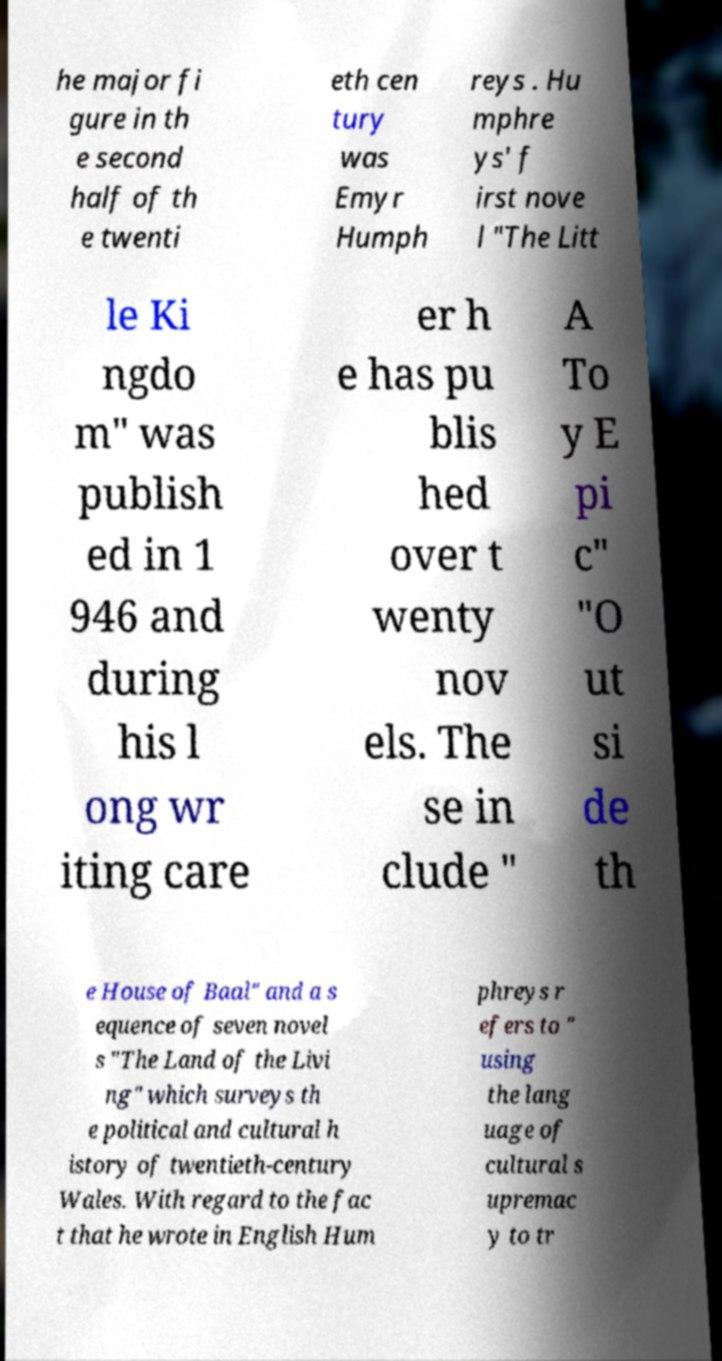For documentation purposes, I need the text within this image transcribed. Could you provide that? he major fi gure in th e second half of th e twenti eth cen tury was Emyr Humph reys . Hu mphre ys' f irst nove l "The Litt le Ki ngdo m" was publish ed in 1 946 and during his l ong wr iting care er h e has pu blis hed over t wenty nov els. The se in clude " A To y E pi c" "O ut si de th e House of Baal" and a s equence of seven novel s "The Land of the Livi ng" which surveys th e political and cultural h istory of twentieth-century Wales. With regard to the fac t that he wrote in English Hum phreys r efers to " using the lang uage of cultural s upremac y to tr 